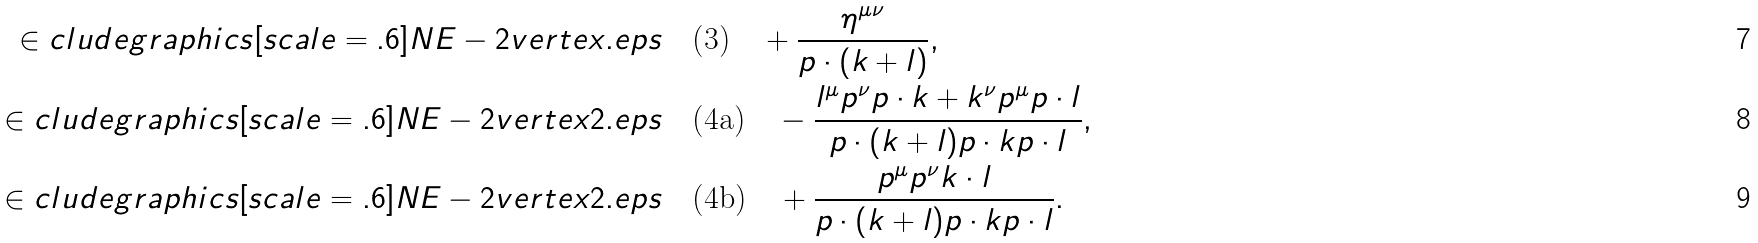<formula> <loc_0><loc_0><loc_500><loc_500>\in c l u d e g r a p h i c s [ s c a l e = . 6 ] { N E - 2 v e r t e x . e p s } & \quad \text {(3)} \quad + \frac { \eta ^ { \mu \nu } } { p \cdot ( k + l ) } , \\ \in c l u d e g r a p h i c s [ s c a l e = . 6 ] { N E - 2 v e r t e x 2 . e p s } & \quad \text {(4a)} \quad - \frac { l ^ { \mu } p ^ { \nu } p \cdot k + k ^ { \nu } p ^ { \mu } p \cdot l } { p \cdot ( k + l ) p \cdot k p \cdot l } , \\ \in c l u d e g r a p h i c s [ s c a l e = . 6 ] { N E - 2 v e r t e x 2 . e p s } & \quad \text {(4b)} \quad + \frac { p ^ { \mu } p ^ { \nu } k \cdot l } { p \cdot ( k + l ) p \cdot k p \cdot l } .</formula> 